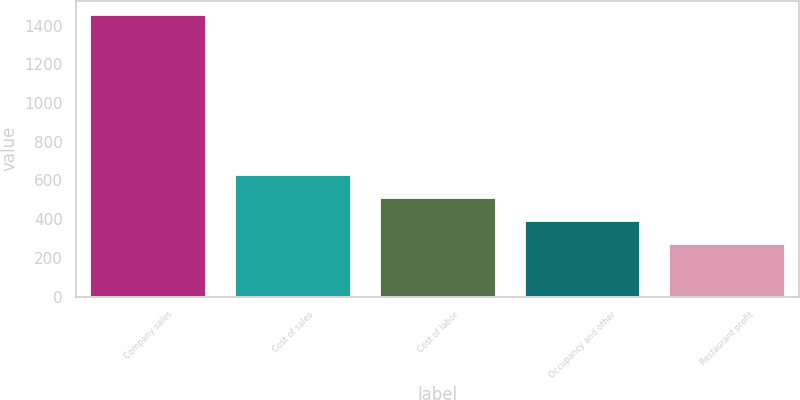Convert chart. <chart><loc_0><loc_0><loc_500><loc_500><bar_chart><fcel>Company sales<fcel>Cost of sales<fcel>Cost of labor<fcel>Occupancy and other<fcel>Restaurant profit<nl><fcel>1454<fcel>628<fcel>510<fcel>392<fcel>274<nl></chart> 